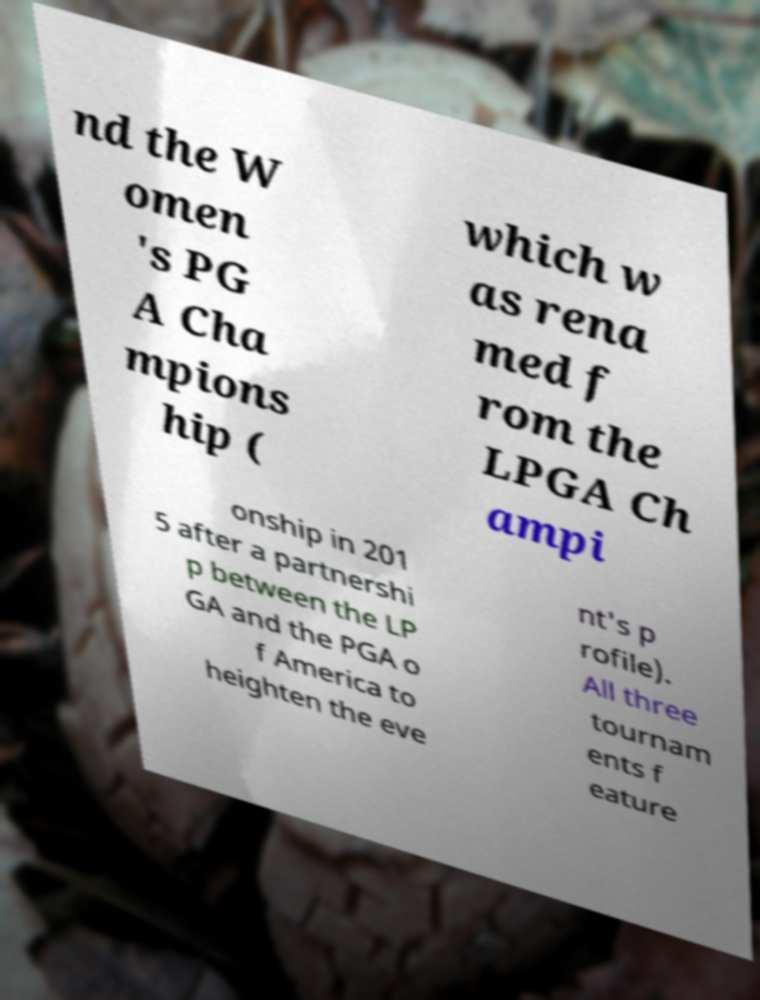There's text embedded in this image that I need extracted. Can you transcribe it verbatim? nd the W omen 's PG A Cha mpions hip ( which w as rena med f rom the LPGA Ch ampi onship in 201 5 after a partnershi p between the LP GA and the PGA o f America to heighten the eve nt's p rofile). All three tournam ents f eature 